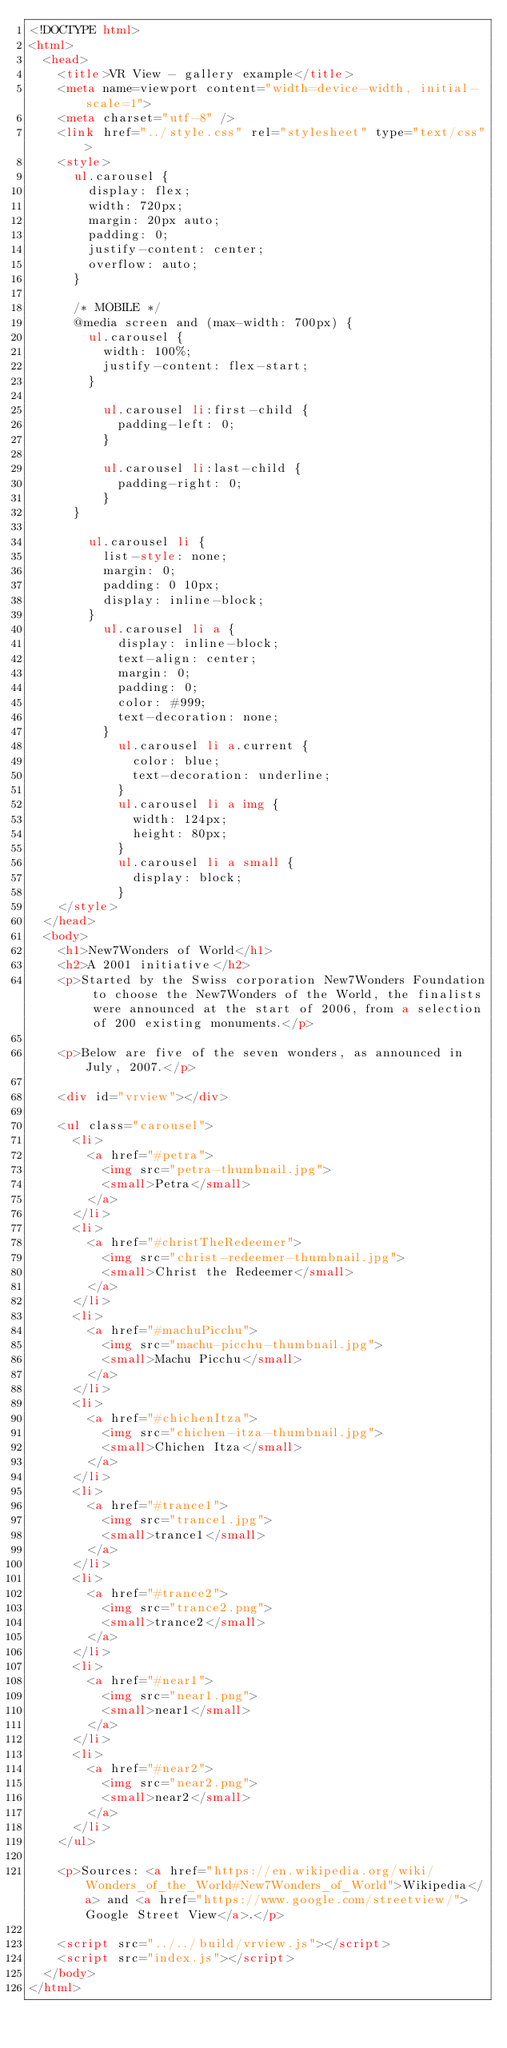<code> <loc_0><loc_0><loc_500><loc_500><_HTML_><!DOCTYPE html>
<html>
  <head>
    <title>VR View - gallery example</title>
    <meta name=viewport content="width=device-width, initial-scale=1">
    <meta charset="utf-8" />
    <link href="../style.css" rel="stylesheet" type="text/css">
    <style>
      ul.carousel {
        display: flex;
        width: 720px;
        margin: 20px auto;
        padding: 0;
        justify-content: center;
        overflow: auto;
      }

      /* MOBILE */
      @media screen and (max-width: 700px) {
        ul.carousel {
          width: 100%;
          justify-content: flex-start;
        }

          ul.carousel li:first-child {
            padding-left: 0;
          }

          ul.carousel li:last-child {
            padding-right: 0;
          }
      }

        ul.carousel li {
          list-style: none;
          margin: 0;
          padding: 0 10px;
          display: inline-block;
        }
          ul.carousel li a {
            display: inline-block;
            text-align: center;
            margin: 0;
            padding: 0;
            color: #999;
            text-decoration: none;
          }
            ul.carousel li a.current {
              color: blue;
              text-decoration: underline;
            }
            ul.carousel li a img {
              width: 124px;
              height: 80px;
            }
            ul.carousel li a small {
              display: block;
            }
    </style>
  </head>
  <body>
    <h1>New7Wonders of World</h1>
    <h2>A 2001 initiative</h2>
    <p>Started by the Swiss corporation New7Wonders Foundation to choose the New7Wonders of the World, the finalists were announced at the start of 2006, from a selection of 200 existing monuments.</p>

    <p>Below are five of the seven wonders, as announced in July, 2007.</p>

    <div id="vrview"></div>

    <ul class="carousel">
      <li>
        <a href="#petra">
          <img src="petra-thumbnail.jpg">
          <small>Petra</small>
        </a>
      </li>
      <li>
        <a href="#christTheRedeemer">
          <img src="christ-redeemer-thumbnail.jpg">
          <small>Christ the Redeemer</small>
        </a>
      </li>
      <li>
        <a href="#machuPicchu">
          <img src="machu-picchu-thumbnail.jpg">
          <small>Machu Picchu</small>
        </a>
      </li>
      <li>
        <a href="#chichenItza">
          <img src="chichen-itza-thumbnail.jpg">
          <small>Chichen Itza</small>
        </a>
      </li>
      <li>
        <a href="#trance1">
          <img src="trance1.jpg">
          <small>trance1</small>
        </a>
      </li>
      <li>
        <a href="#trance2">
          <img src="trance2.png">
          <small>trance2</small>
        </a>
      </li>
      <li>
        <a href="#near1">
          <img src="near1.png">
          <small>near1</small>
        </a>
      </li>
      <li>
        <a href="#near2">
          <img src="near2.png">
          <small>near2</small>
        </a>
      </li>
    </ul>

    <p>Sources: <a href="https://en.wikipedia.org/wiki/Wonders_of_the_World#New7Wonders_of_World">Wikipedia</a> and <a href="https://www.google.com/streetview/">Google Street View</a>.</p>

    <script src="../../build/vrview.js"></script>
    <script src="index.js"></script>
  </body>
</html>
</code> 